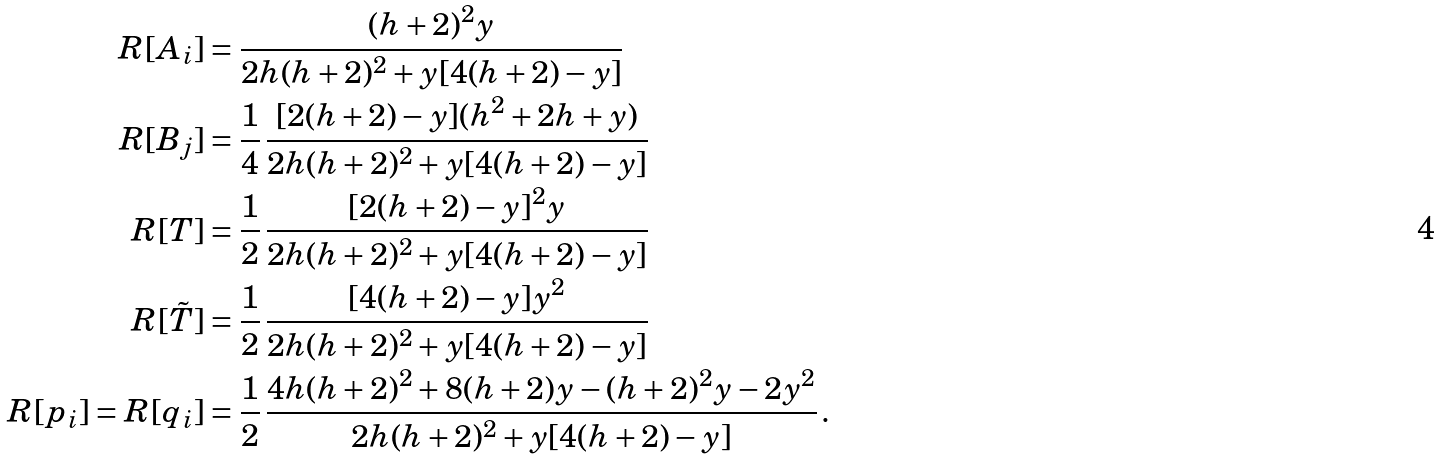Convert formula to latex. <formula><loc_0><loc_0><loc_500><loc_500>R [ A _ { i } ] & = \frac { ( h + 2 ) ^ { 2 } y } { 2 h ( h + 2 ) ^ { 2 } + y [ 4 ( h + 2 ) - y ] } \\ R [ B _ { j } ] & = \frac { 1 } { 4 } \, \frac { [ 2 ( h + 2 ) - y ] ( h ^ { 2 } + 2 h + y ) } { 2 h ( h + 2 ) ^ { 2 } + y [ 4 ( h + 2 ) - y ] } \\ R [ T ] & = \frac { 1 } { 2 } \, \frac { [ 2 ( h + 2 ) - y ] ^ { 2 } y } { 2 h ( h + 2 ) ^ { 2 } + y [ 4 ( h + 2 ) - y ] } \\ R [ \tilde { T } ] & = \frac { 1 } { 2 } \, \frac { [ 4 ( h + 2 ) - y ] y ^ { 2 } } { 2 h ( h + 2 ) ^ { 2 } + y [ 4 ( h + 2 ) - y ] } \\ R [ p _ { i } ] = R [ q _ { i } ] & = \frac { 1 } { 2 } \, \frac { 4 h ( h + 2 ) ^ { 2 } + 8 ( h + 2 ) y - ( h + 2 ) ^ { 2 } y - 2 y ^ { 2 } } { 2 h ( h + 2 ) ^ { 2 } + y [ 4 ( h + 2 ) - y ] } \, .</formula> 